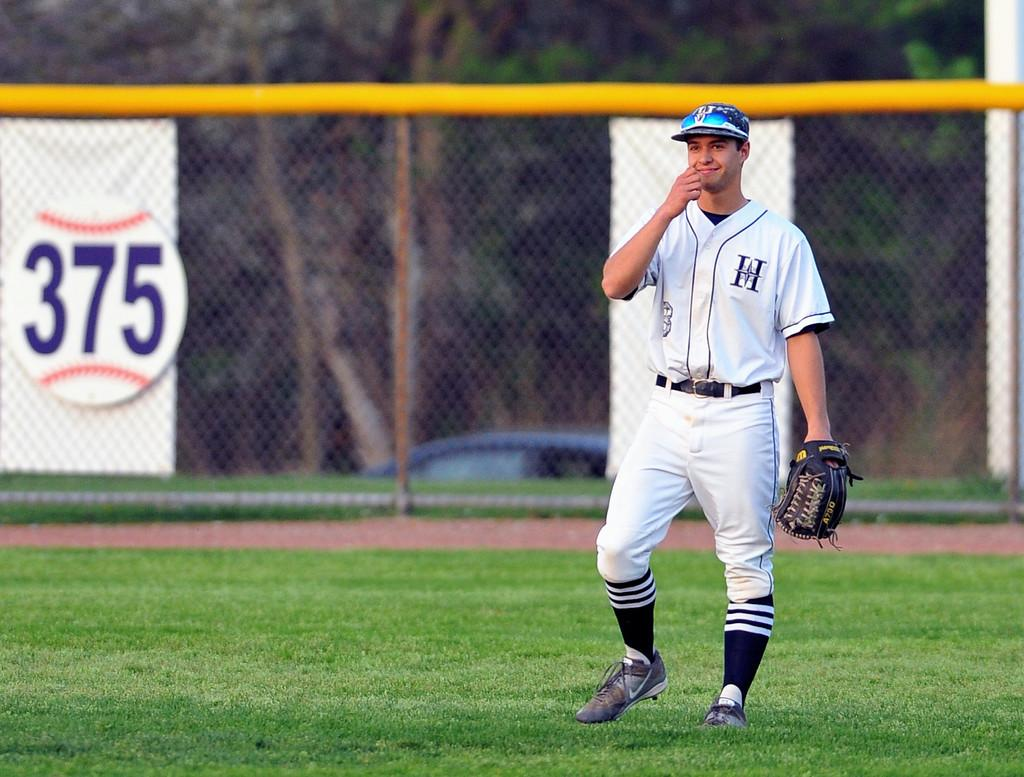Provide a one-sentence caption for the provided image. a person with a jersey on with the letter H. 